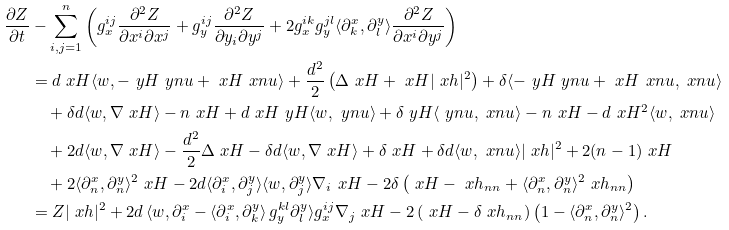<formula> <loc_0><loc_0><loc_500><loc_500>\frac { \partial Z } { \partial t } & - \sum _ { i , j = 1 } ^ { n } \left ( g _ { x } ^ { i j } \frac { \partial ^ { 2 } Z } { \partial x ^ { i } \partial x ^ { j } } + g _ { y } ^ { i j } \frac { \partial ^ { 2 } Z } { \partial y _ { i } \partial y ^ { j } } + 2 g _ { x } ^ { i k } g _ { y } ^ { j l } \langle \partial ^ { x } _ { k } , \partial ^ { y } _ { l } \rangle \frac { \partial ^ { 2 } Z } { \partial x ^ { i } \partial y ^ { j } } \right ) \\ & = d \ x H \langle w , - \ y H \ y n u + \ x H \ x n u \rangle + \frac { d ^ { 2 } } { 2 } \left ( \Delta \ x H + \ x H | \ x h | ^ { 2 } \right ) + \delta \langle - \ y H \ y n u + \ x H \ x n u , \ x n u \rangle \\ & \quad \null + \delta d \langle w , \nabla \ x H \rangle - n \ x H + d \ x H \ y H \langle w , \ y n u \rangle + \delta \ y H \langle \ y n u , \ x n u \rangle - n \ x H - d \ x H ^ { 2 } \langle w , \ x n u \rangle \\ & \quad \null + 2 d \langle w , \nabla \ x H \rangle - \frac { d ^ { 2 } } { 2 } \Delta \ x H - \delta d \langle w , \nabla \ x H \rangle + \delta \ x H + \delta d \langle w , \ x n u \rangle | \ x h | ^ { 2 } + 2 ( n - 1 ) \ x H \\ & \quad \null + 2 \langle \partial ^ { x } _ { n } , \partial ^ { y } _ { n } \rangle ^ { 2 } \ x H - 2 d \langle \partial ^ { x } _ { i } , \partial ^ { y } _ { j } \rangle \langle w , \partial ^ { y } _ { j } \rangle \nabla _ { i } \ x H - 2 \delta \left ( \ x H - \ x h _ { n n } + \langle \partial ^ { x } _ { n } , \partial ^ { y } _ { n } \rangle ^ { 2 } \ x h _ { n n } \right ) \\ & = Z | \ x h | ^ { 2 } + 2 d \left \langle w , \partial ^ { x } _ { i } - \langle \partial ^ { x } _ { i } , \partial ^ { y } _ { k } \right \rangle g _ { y } ^ { k l } \partial ^ { y } _ { l } \rangle g _ { x } ^ { i j } \nabla _ { j } \ x H - 2 \left ( \ x H - \delta \ x h _ { n n } \right ) \left ( 1 - \langle \partial ^ { x } _ { n } , \partial ^ { y } _ { n } \rangle ^ { 2 } \right ) .</formula> 